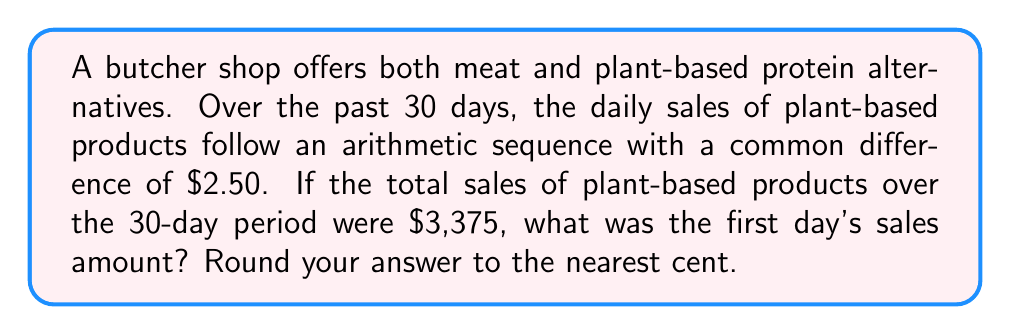Teach me how to tackle this problem. Let's approach this step-by-step using the arithmetic sequence formula and the sum of an arithmetic sequence:

1) Let $a$ be the first term (first day's sales) and $d$ be the common difference ($2.50).

2) The arithmetic sequence formula for the nth term is:
   $a_n = a + (n-1)d$

3) The sum of an arithmetic sequence with n terms is given by:
   $S_n = \frac{n}{2}(a_1 + a_n)$, where $a_1$ is the first term and $a_n$ is the last term.

4) We know:
   $n = 30$ (days)
   $d = 2.50$
   $S_{30} = 3375$

5) The last term, $a_{30} = a + (30-1)2.50 = a + 72.50$

6) Substituting into the sum formula:
   $3375 = \frac{30}{2}(a + (a + 72.50))$

7) Simplifying:
   $3375 = 15(2a + 72.50)$
   $3375 = 30a + 1087.50$

8) Solving for $a$:
   $2287.50 = 30a$
   $a = 76.25$

Therefore, the first day's sales amount was $76.25.
Answer: $76.25 